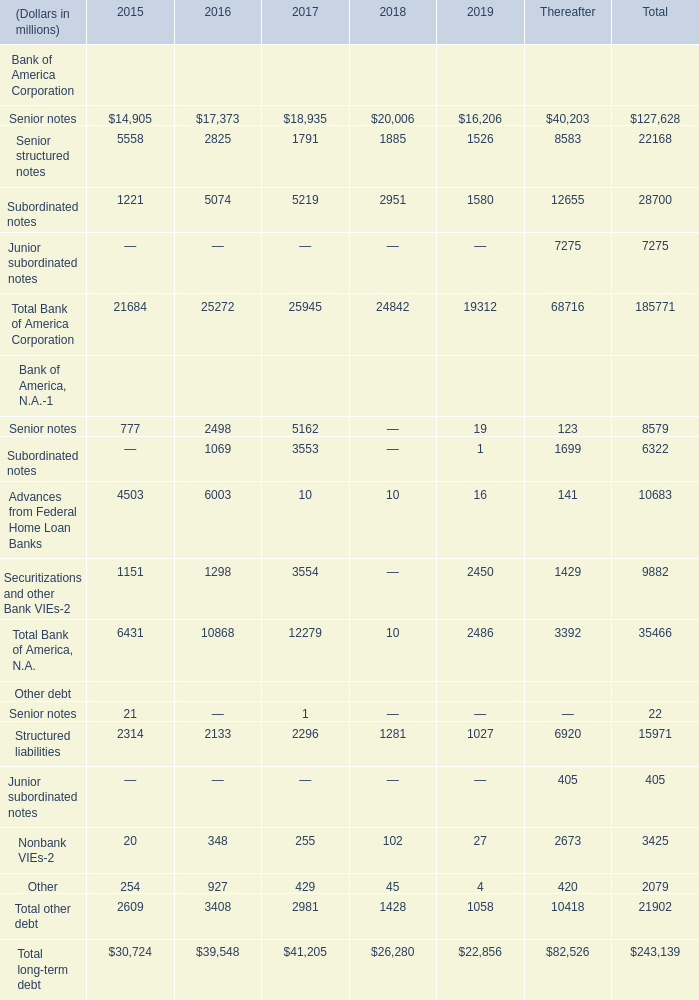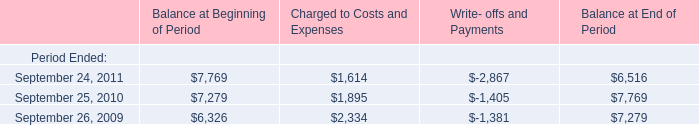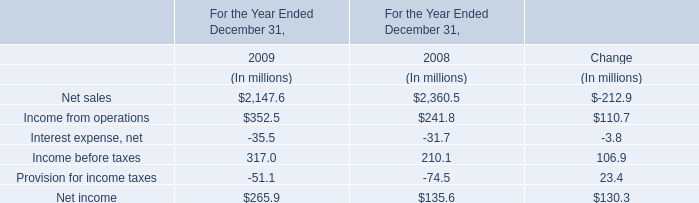What will Total long-term debt be like in 2020 if it continues to grow at the same rate as it did in 2019? (in million) 
Computations: (22856 * (1 + ((22856 - 26280) / 26280)))
Answer: 19878.1102. 